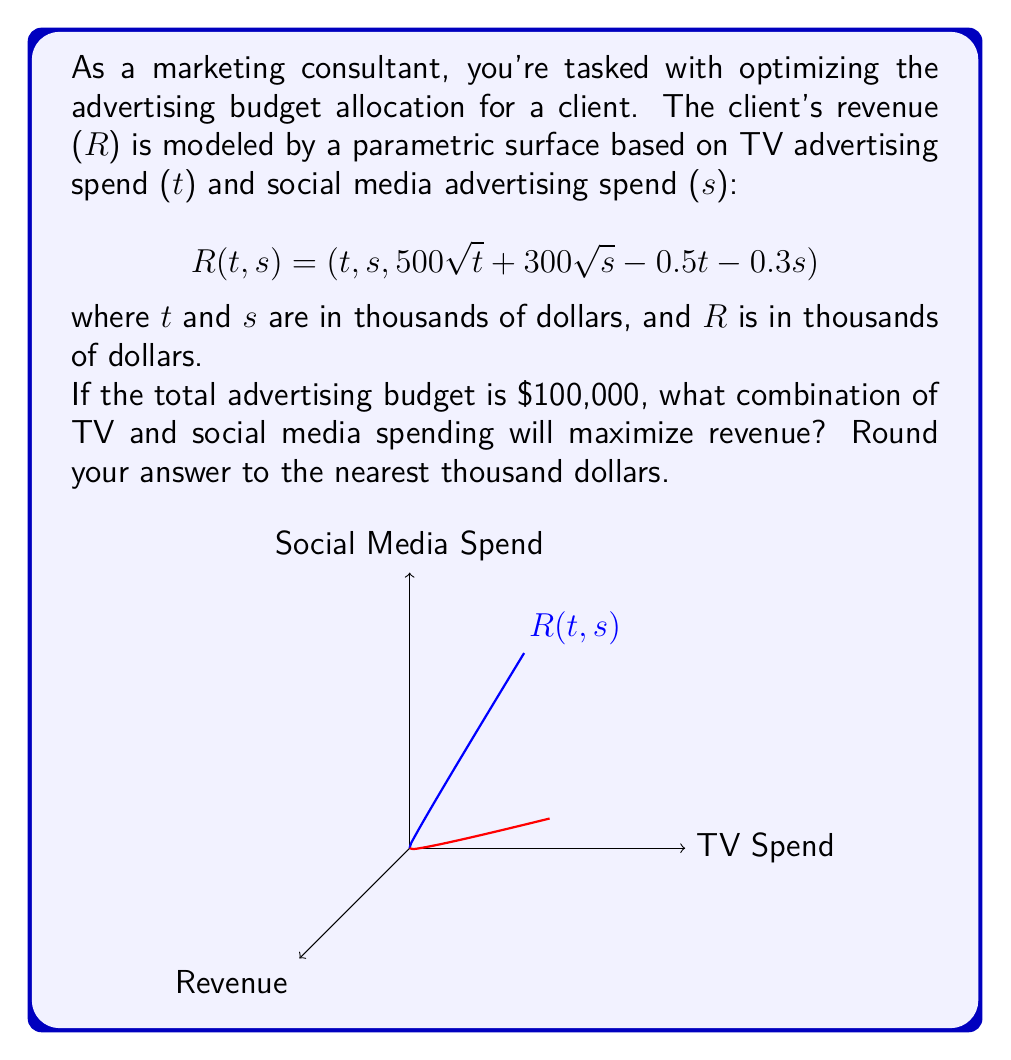Can you answer this question? Let's approach this step-by-step:

1) We need to maximize R subject to the constraint that t + s = 100 (since the total budget is $100,000).

2) We can substitute s = 100 - t into the revenue function:

   $$R(t) = 500\sqrt{t} + 300\sqrt{100-t} - 0.5t - 0.3(100-t)$$

3) To find the maximum, we differentiate R with respect to t and set it to zero:

   $$\frac{dR}{dt} = \frac{250}{\sqrt{t}} - \frac{150}{\sqrt{100-t}} - 0.5 + 0.3 = 0$$

4) Simplifying:

   $$\frac{250}{\sqrt{t}} - \frac{150}{\sqrt{100-t}} = 0.2$$

5) Squaring both sides:

   $$\frac{62500}{t} + \frac{22500}{100-t} - \frac{75000}{\sqrt{t(100-t)}} = 0.04$$

6) This equation is complex and doesn't have a nice analytical solution. We can solve it numerically using methods like Newton-Raphson.

7) Using numerical methods, we find that t ≈ 69.44

8) Since s = 100 - t, s ≈ 30.56

9) Rounding to the nearest thousand:
   TV spend (t) ≈ $69,000
   Social media spend (s) ≈ $31,000
Answer: TV: $69,000, Social Media: $31,000 